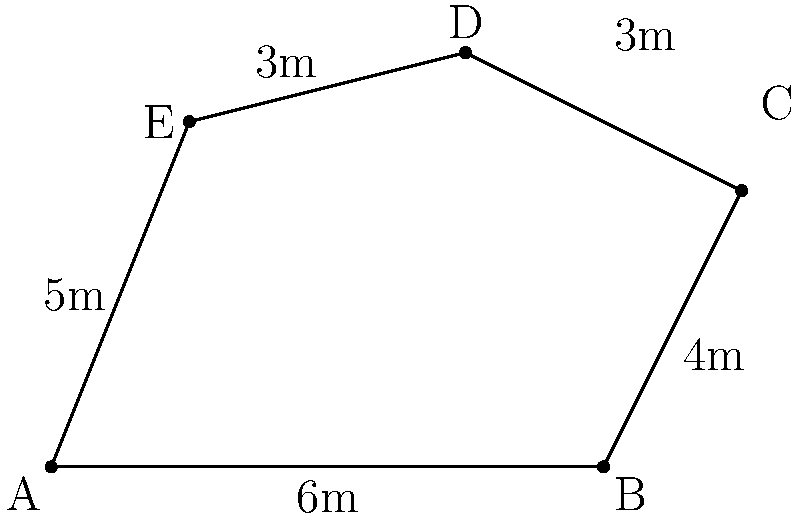As a tax advisor working on an international project, you need to calculate the area of an irregularly shaped office space in a new EU branch. The office has been divided into triangles for easier measurement. Given the dimensions shown in the diagram, what is the total area of the office space in square meters? To calculate the area of the irregular office space, we'll use the triangulation method:

1. Divide the space into three triangles: ABE, BCE, and CDE.

2. Calculate the area of each triangle using the formula: $A = \frac{1}{2} \times base \times height$

3. For triangle ABE:
   Base (AB) = 6m
   Height (perpendicular from E to AB) = 5m
   Area_ABE = $\frac{1}{2} \times 6 \times 5 = 15$ sq m

4. For triangle BCE:
   We need to find the height first. We can do this by using the Pythagorean theorem:
   $height^2 + 2^2 = 4^2$
   $height^2 = 16 - 4 = 12$
   $height = \sqrt{12} = 2\sqrt{3}$ m
   
   Base (BC) = 4m
   Area_BCE = $\frac{1}{2} \times 4 \times 2\sqrt{3} = 4\sqrt{3}$ sq m

5. For triangle CDE:
   Base (CD) = 3m
   Height (perpendicular from E to CD) = 2m
   Area_CDE = $\frac{1}{2} \times 3 \times 2 = 3$ sq m

6. Total area = Area_ABE + Area_BCE + Area_CDE
               = $15 + 4\sqrt{3} + 3$
               = $18 + 4\sqrt{3}$ sq m
Answer: $18 + 4\sqrt{3}$ sq m 